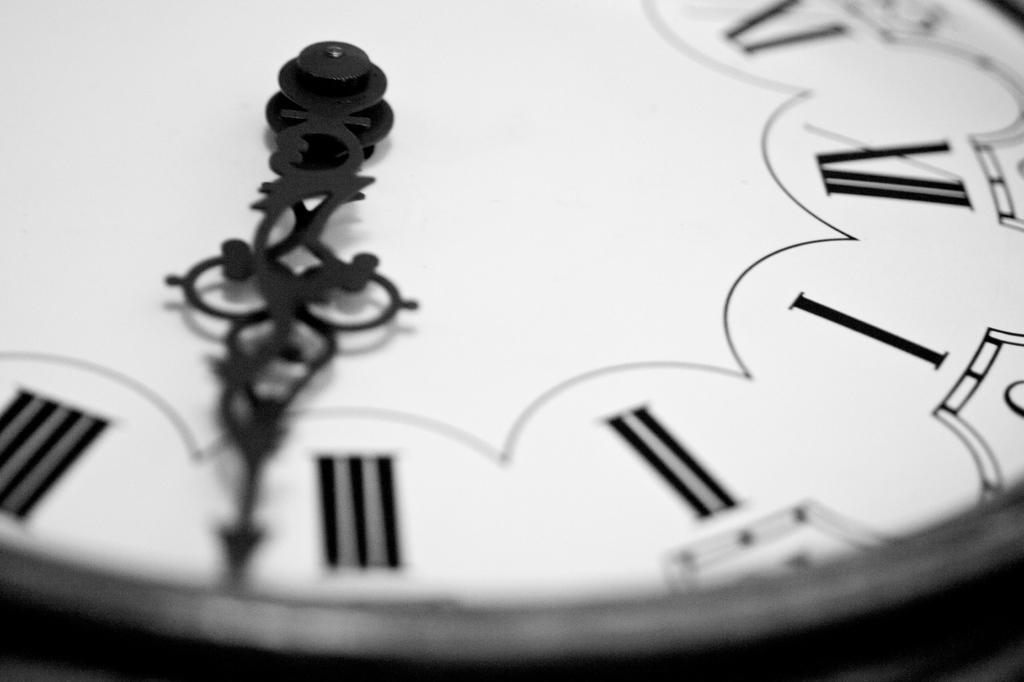<image>
Describe the image concisely. the roman numeral III is on the white face of the clock 